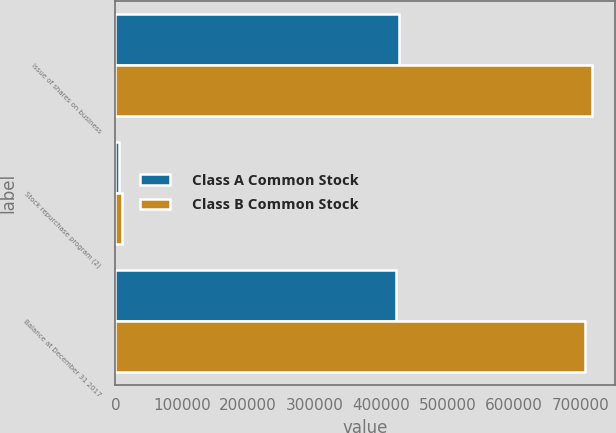<chart> <loc_0><loc_0><loc_500><loc_500><stacked_bar_chart><ecel><fcel>Issue of shares on business<fcel>Stock repurchase program (2)<fcel>Balance at December 31 2017<nl><fcel>Class A Common Stock<fcel>427709<fcel>6047<fcel>422208<nl><fcel>Class B Common Stock<fcel>717111<fcel>10126<fcel>706985<nl></chart> 